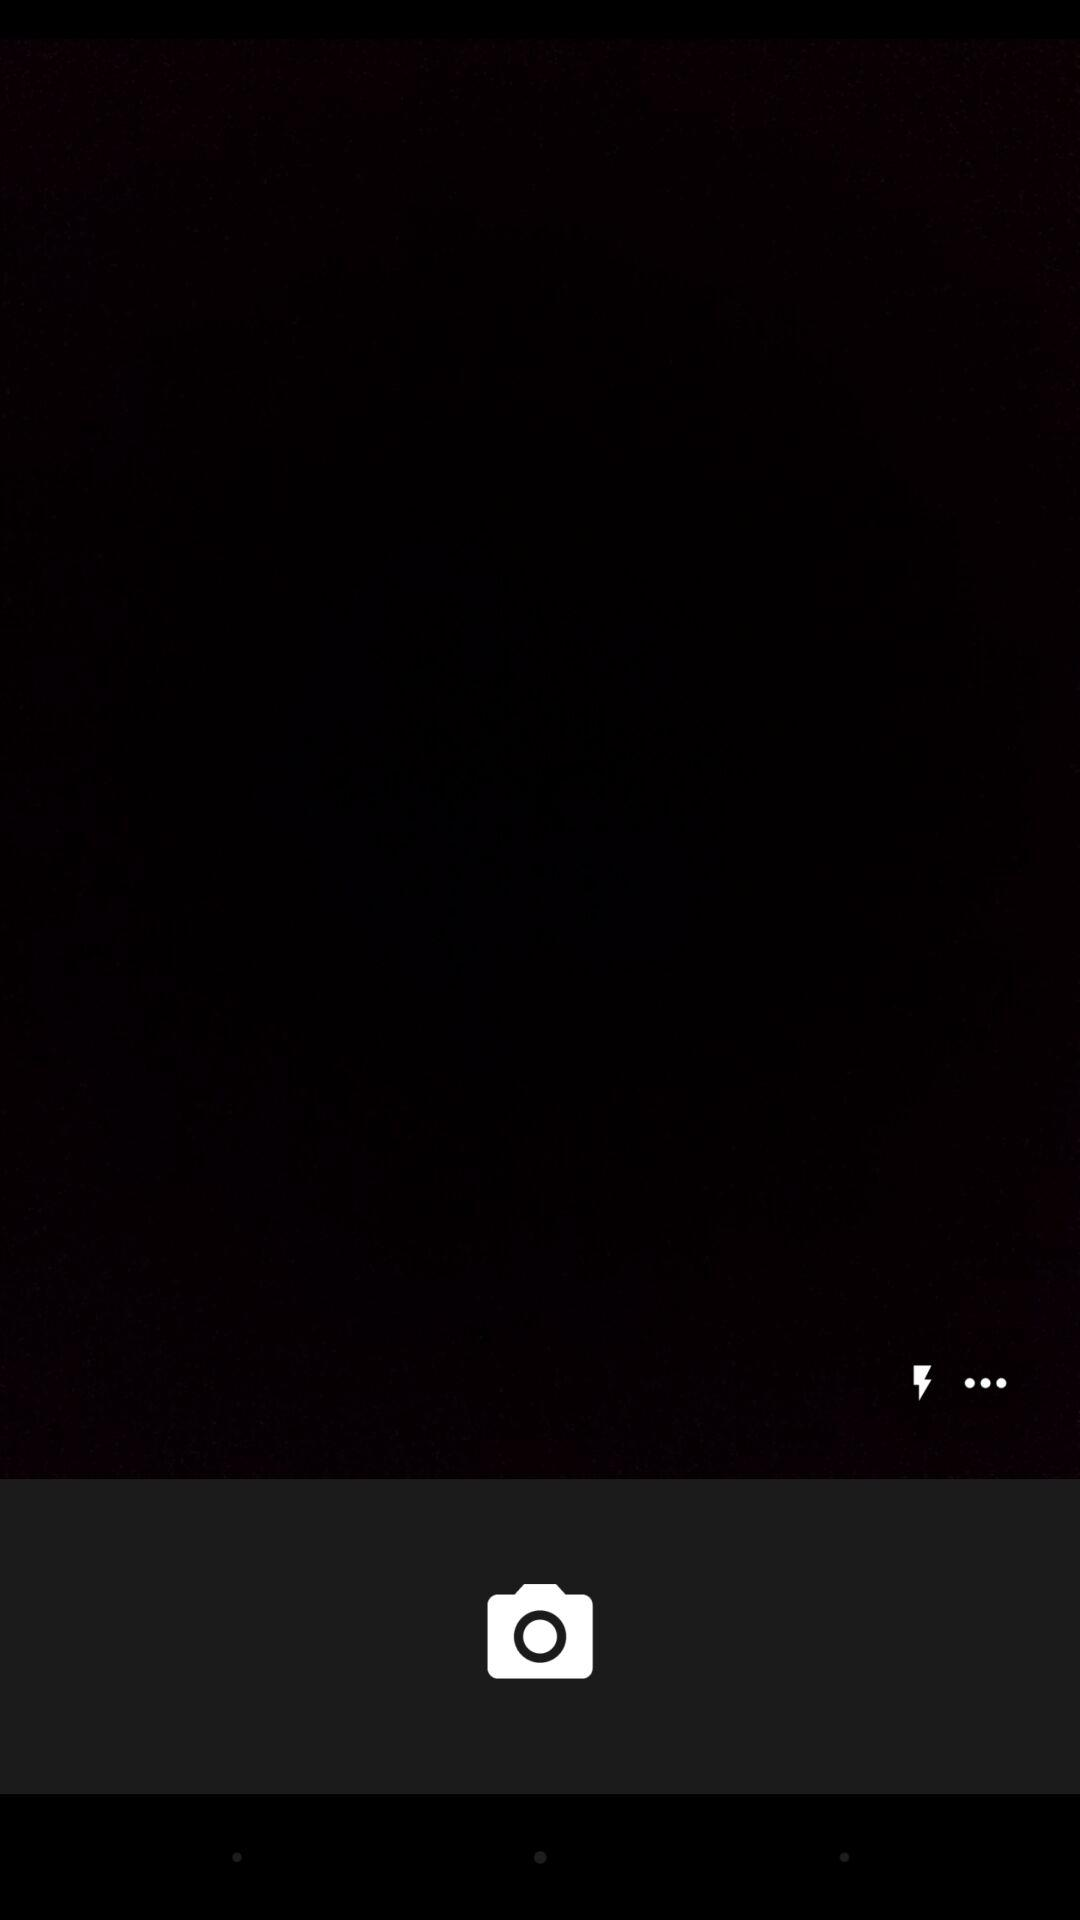How many more dots are there than lightning bolts?
Answer the question using a single word or phrase. 2 